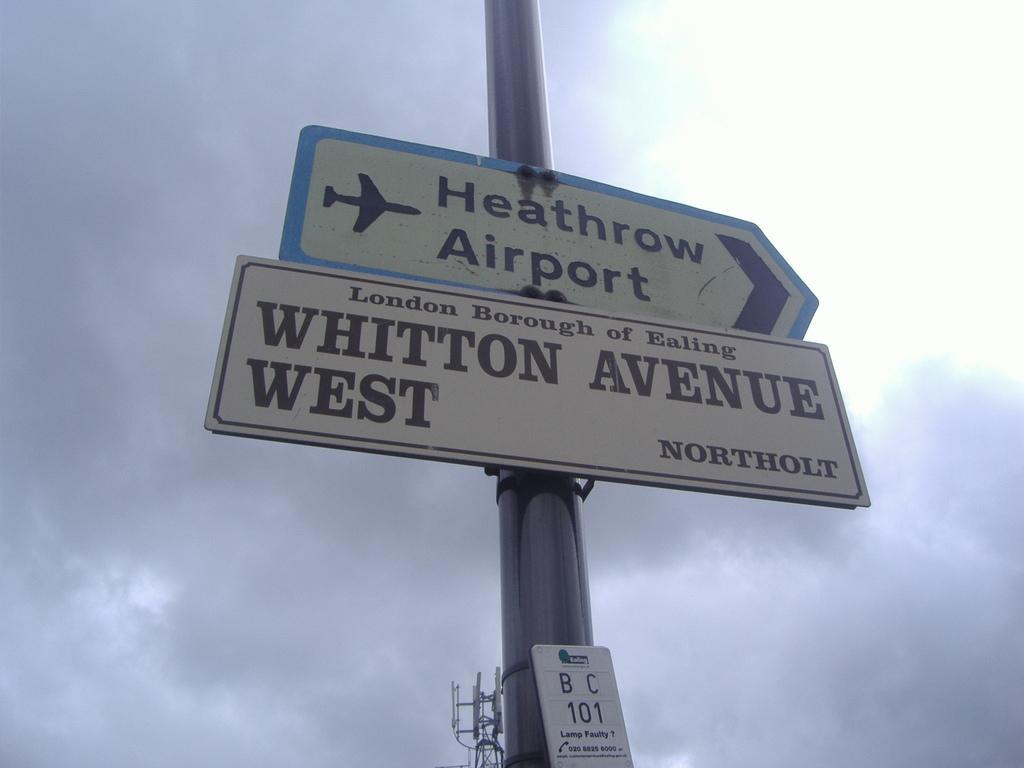Can you describe this image briefly? In this image we can see a pole with sign boards. In the background there is sky with clouds. At the bottom we can see a tower. 